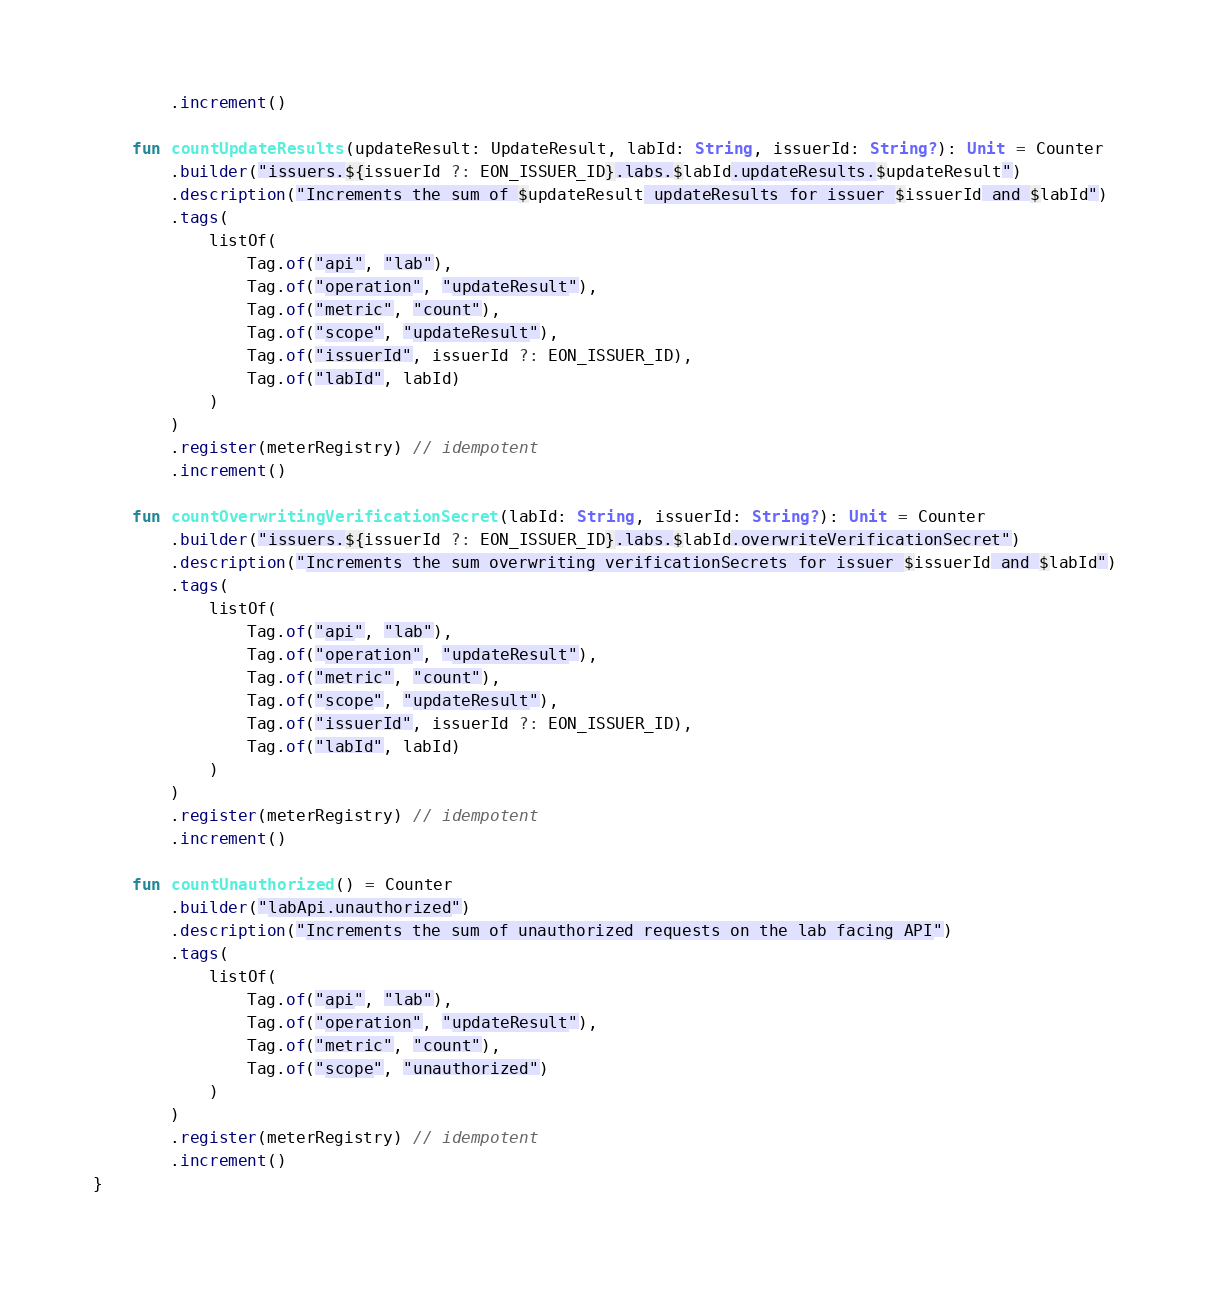<code> <loc_0><loc_0><loc_500><loc_500><_Kotlin_>        .increment()

    fun countUpdateResults(updateResult: UpdateResult, labId: String, issuerId: String?): Unit = Counter
        .builder("issuers.${issuerId ?: EON_ISSUER_ID}.labs.$labId.updateResults.$updateResult")
        .description("Increments the sum of $updateResult updateResults for issuer $issuerId and $labId")
        .tags(
            listOf(
                Tag.of("api", "lab"),
                Tag.of("operation", "updateResult"),
                Tag.of("metric", "count"),
                Tag.of("scope", "updateResult"),
                Tag.of("issuerId", issuerId ?: EON_ISSUER_ID),
                Tag.of("labId", labId)
            )
        )
        .register(meterRegistry) // idempotent
        .increment()

    fun countOverwritingVerificationSecret(labId: String, issuerId: String?): Unit = Counter
        .builder("issuers.${issuerId ?: EON_ISSUER_ID}.labs.$labId.overwriteVerificationSecret")
        .description("Increments the sum overwriting verificationSecrets for issuer $issuerId and $labId")
        .tags(
            listOf(
                Tag.of("api", "lab"),
                Tag.of("operation", "updateResult"),
                Tag.of("metric", "count"),
                Tag.of("scope", "updateResult"),
                Tag.of("issuerId", issuerId ?: EON_ISSUER_ID),
                Tag.of("labId", labId)
            )
        )
        .register(meterRegistry) // idempotent
        .increment()

    fun countUnauthorized() = Counter
        .builder("labApi.unauthorized")
        .description("Increments the sum of unauthorized requests on the lab facing API")
        .tags(
            listOf(
                Tag.of("api", "lab"),
                Tag.of("operation", "updateResult"),
                Tag.of("metric", "count"),
                Tag.of("scope", "unauthorized")
            )
        )
        .register(meterRegistry) // idempotent
        .increment()
}
</code> 